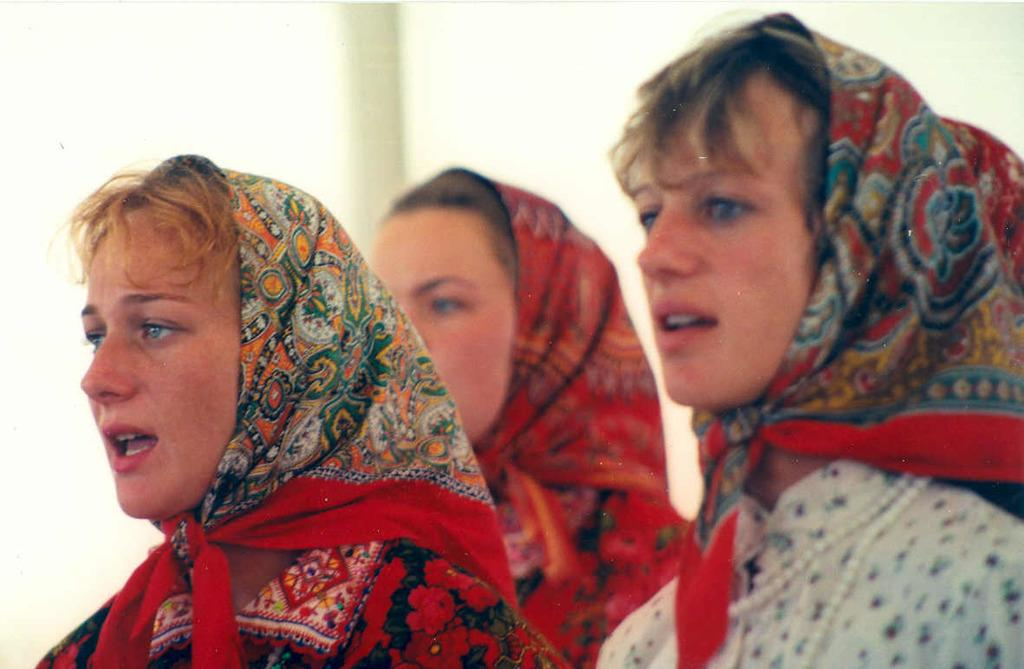What can be seen in the image? There are women standing in the image. What are the women wearing on their heads? The women are covering their heads with scarves. What is visible in the background of the image? There is a wall in the background of the image. What type of wilderness can be seen in the image? There is no wilderness present in the image; it features women standing with scarves on their heads and a wall in the background. How many robins can be seen in the image? There are no robins present in the image. 